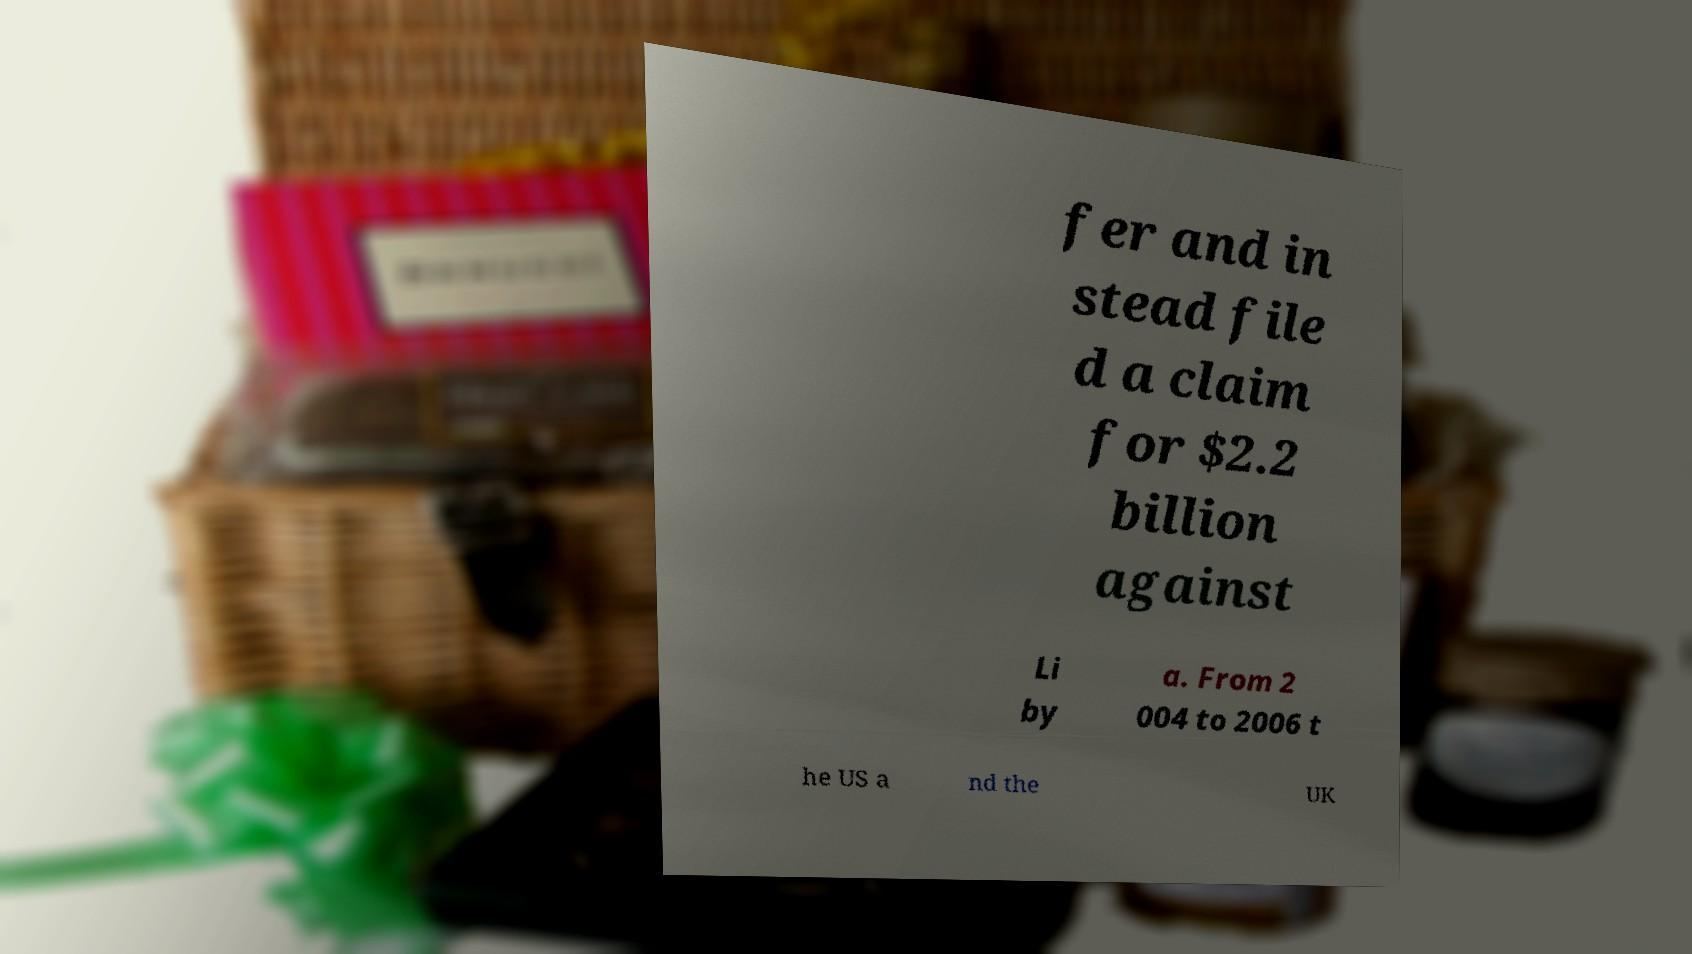Can you read and provide the text displayed in the image?This photo seems to have some interesting text. Can you extract and type it out for me? fer and in stead file d a claim for $2.2 billion against Li by a. From 2 004 to 2006 t he US a nd the UK 